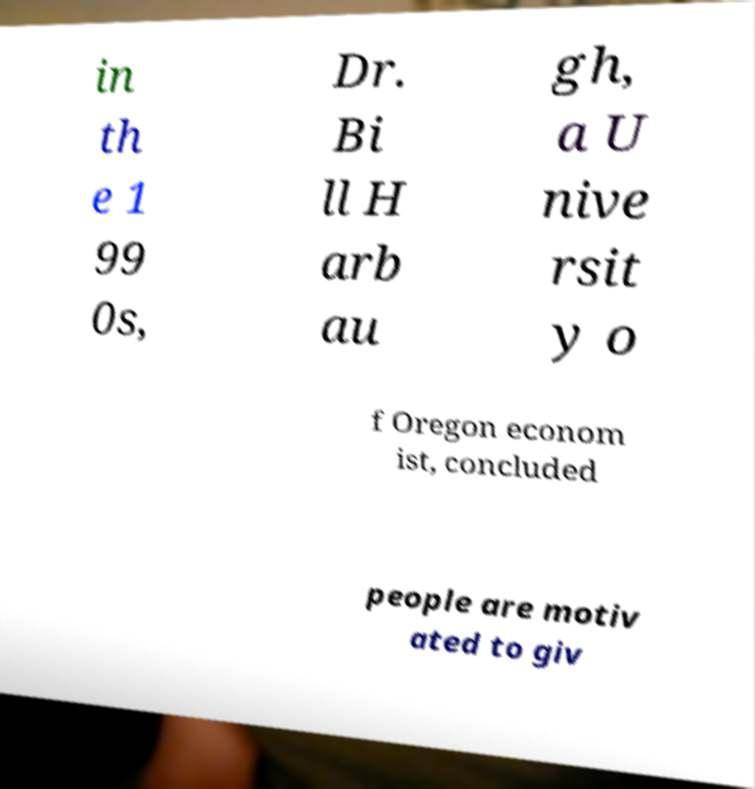There's text embedded in this image that I need extracted. Can you transcribe it verbatim? in th e 1 99 0s, Dr. Bi ll H arb au gh, a U nive rsit y o f Oregon econom ist, concluded people are motiv ated to giv 